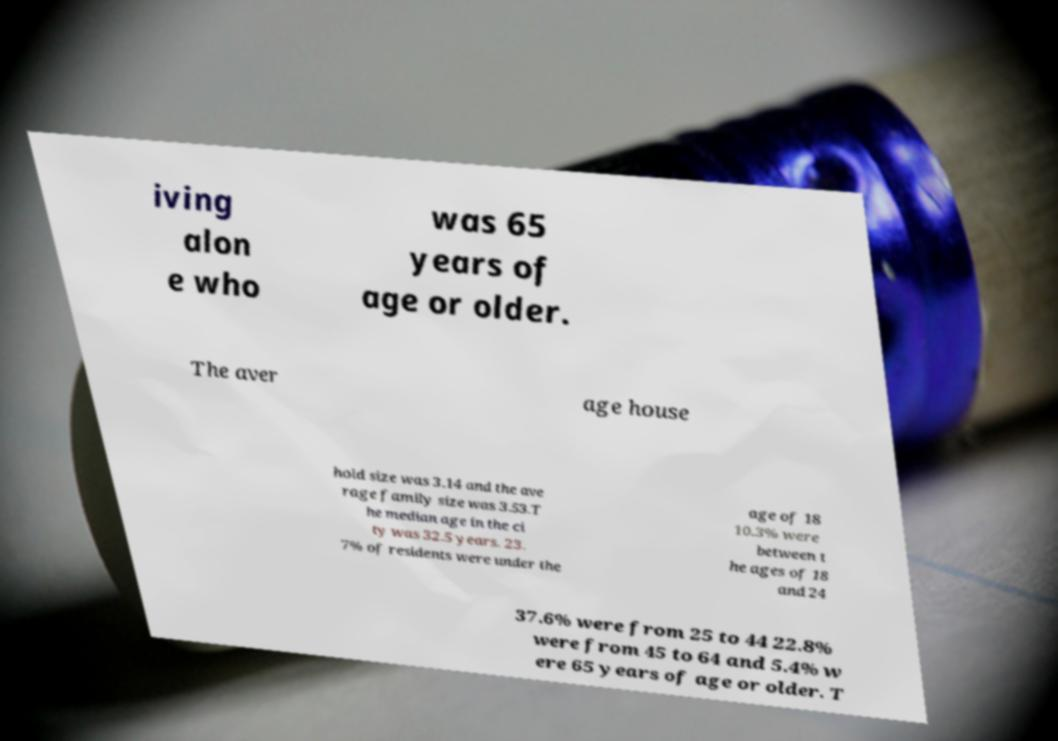What messages or text are displayed in this image? I need them in a readable, typed format. iving alon e who was 65 years of age or older. The aver age house hold size was 3.14 and the ave rage family size was 3.53.T he median age in the ci ty was 32.5 years. 23. 7% of residents were under the age of 18 10.3% were between t he ages of 18 and 24 37.6% were from 25 to 44 22.8% were from 45 to 64 and 5.4% w ere 65 years of age or older. T 